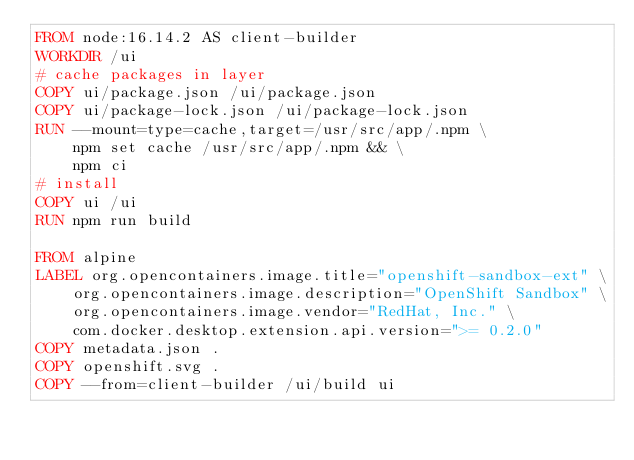<code> <loc_0><loc_0><loc_500><loc_500><_Dockerfile_>FROM node:16.14.2 AS client-builder
WORKDIR /ui
# cache packages in layer
COPY ui/package.json /ui/package.json
COPY ui/package-lock.json /ui/package-lock.json
RUN --mount=type=cache,target=/usr/src/app/.npm \
    npm set cache /usr/src/app/.npm && \
    npm ci
# install
COPY ui /ui
RUN npm run build

FROM alpine
LABEL org.opencontainers.image.title="openshift-sandbox-ext" \
    org.opencontainers.image.description="OpenShift Sandbox" \
    org.opencontainers.image.vendor="RedHat, Inc." \
    com.docker.desktop.extension.api.version=">= 0.2.0"
COPY metadata.json .
COPY openshift.svg .
COPY --from=client-builder /ui/build ui
</code> 